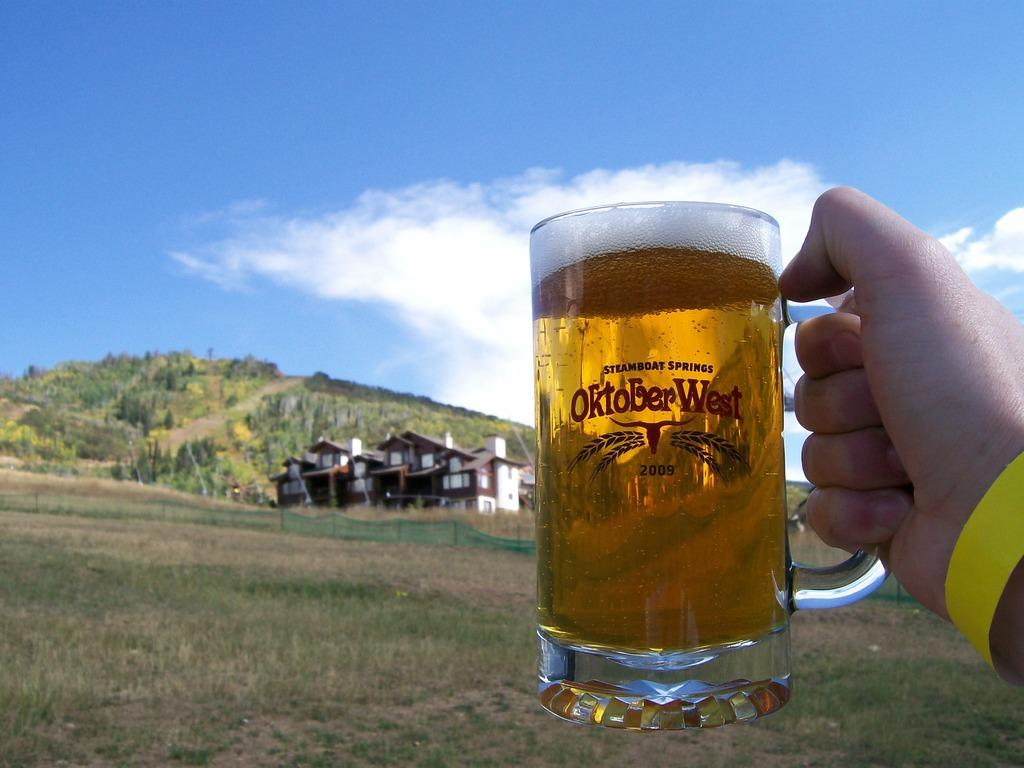<image>
Provide a brief description of the given image. Oktober West is celebrated by the people of Steamboat Springs. 